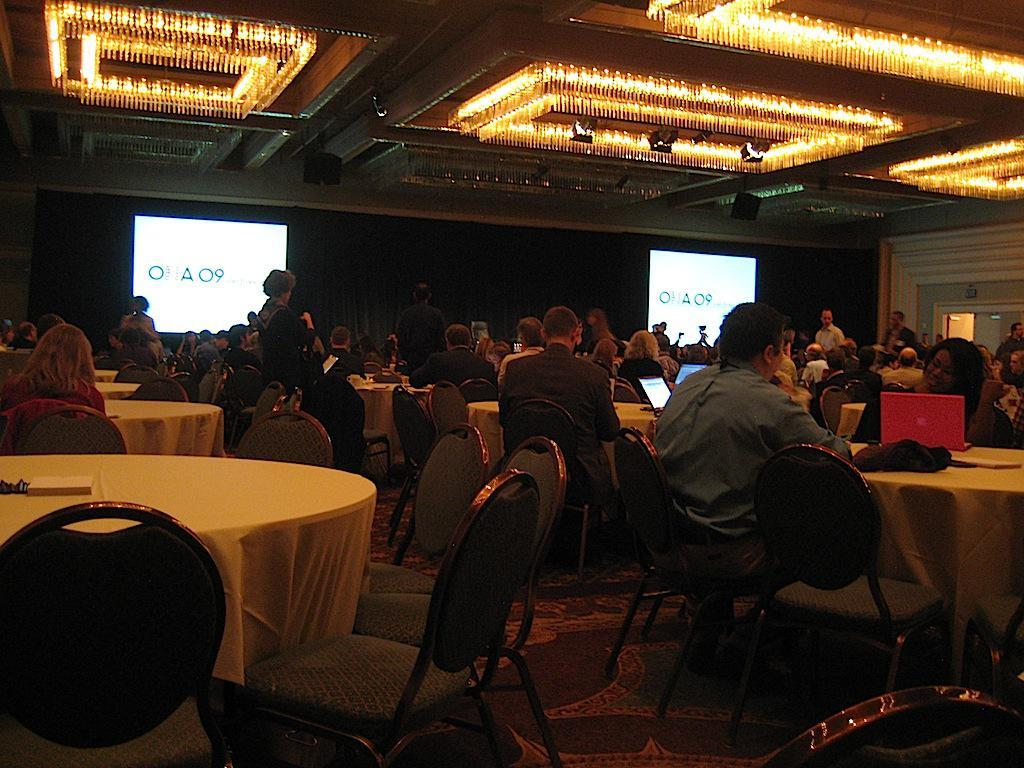What are the people in the image doing? The people in the image are sitting on chairs. What object can be seen on the table in the image? There is a laptop on the table in the image. What is the primary piece of furniture in the image? The primary piece of furniture in the image is a table. What type of creature is sitting on the chair next to the laptop? There is no creature present in the image; only people are visible. 